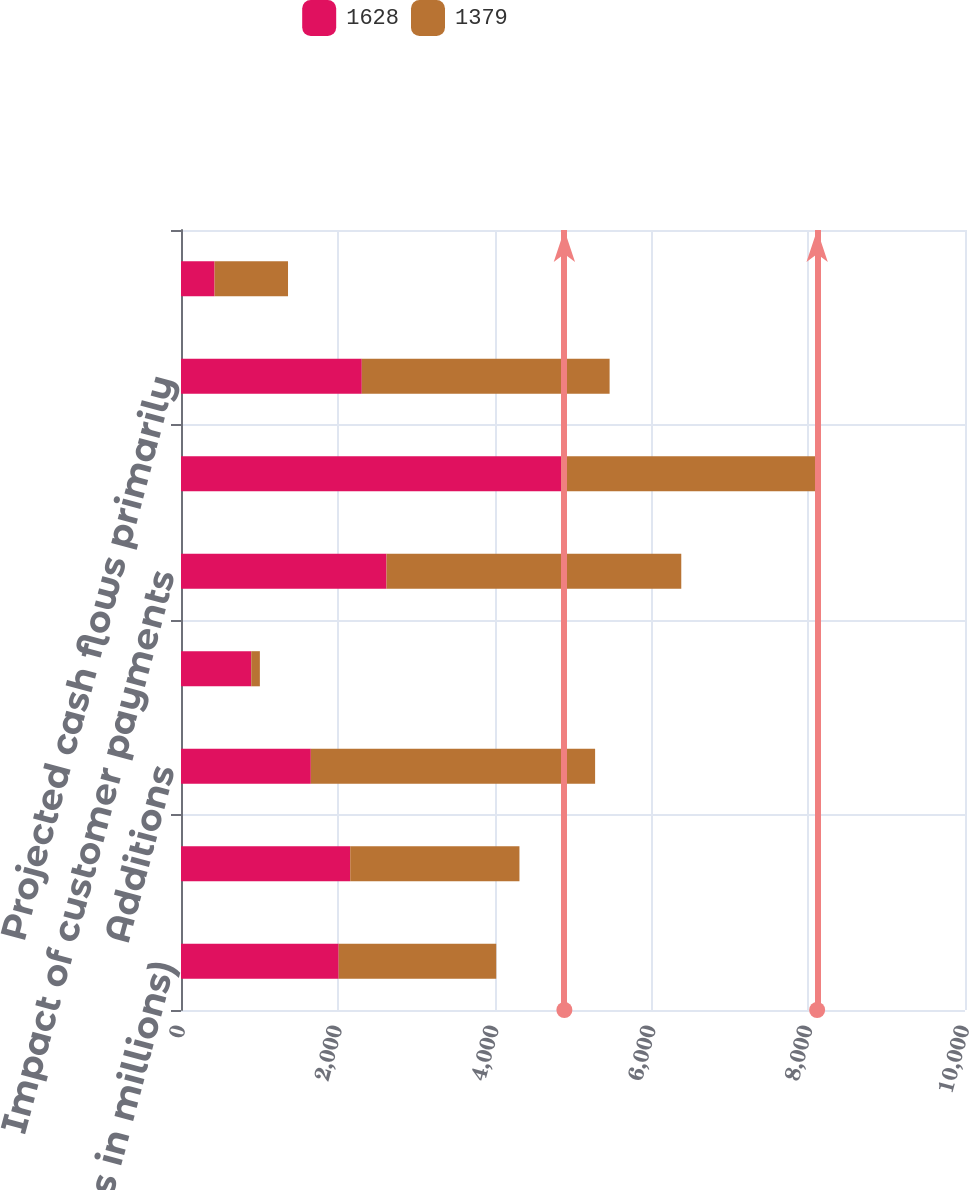Convert chart to OTSL. <chart><loc_0><loc_0><loc_500><loc_500><stacked_bar_chart><ecel><fcel>(Dollars in millions)<fcel>Balance January 1<fcel>Additions<fcel>Sales<fcel>Impact of customer payments<fcel>Impact of changes in interest<fcel>Projected cash flows primarily<fcel>Impact of changes in the Home<nl><fcel>1628<fcel>2011<fcel>2158.5<fcel>1656<fcel>896<fcel>2621<fcel>4890<fcel>2306<fcel>428<nl><fcel>1379<fcel>2010<fcel>2158.5<fcel>3626<fcel>110<fcel>3760<fcel>3224<fcel>3161<fcel>937<nl></chart> 